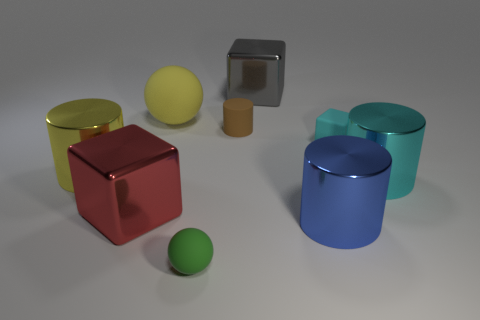Subtract all blue metallic cylinders. How many cylinders are left? 3 Subtract 2 blocks. How many blocks are left? 1 Add 1 yellow matte spheres. How many objects exist? 10 Subtract all cyan cubes. How many cubes are left? 2 Subtract all purple blocks. How many green spheres are left? 1 Add 6 big green matte cubes. How many big green matte cubes exist? 6 Subtract 0 gray balls. How many objects are left? 9 Subtract all cylinders. How many objects are left? 5 Subtract all red cylinders. Subtract all yellow cubes. How many cylinders are left? 4 Subtract all big gray cubes. Subtract all shiny cubes. How many objects are left? 6 